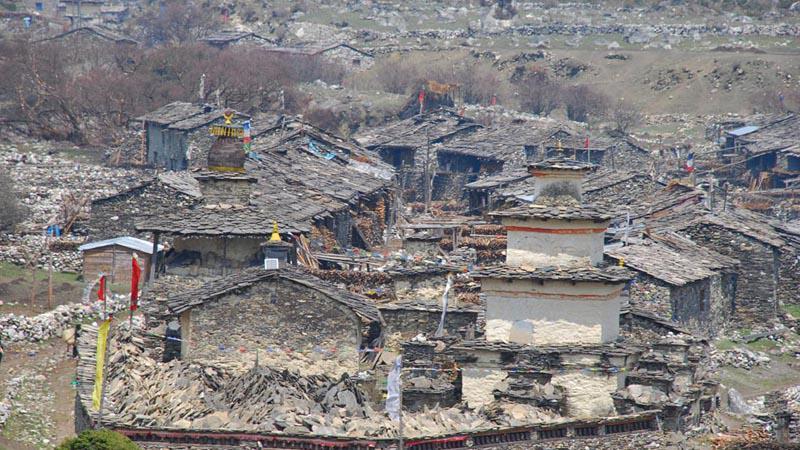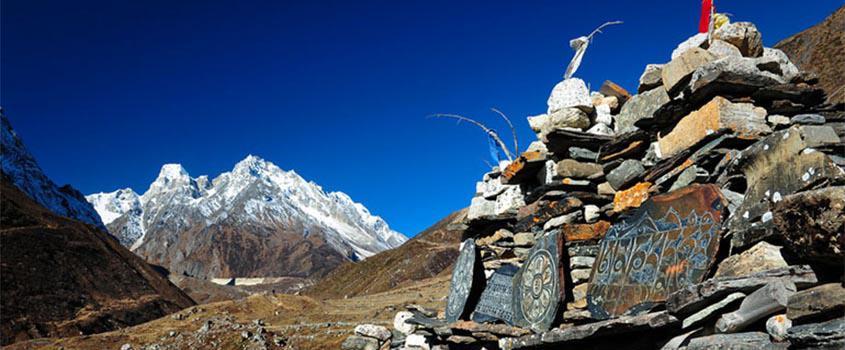The first image is the image on the left, the second image is the image on the right. Analyze the images presented: Is the assertion "An image shows a hillside covered with buildings with windows, and rustic white structures in the foreground." valid? Answer yes or no. No. The first image is the image on the left, the second image is the image on the right. Considering the images on both sides, is "There are flags located on several buildings in one of the images." valid? Answer yes or no. Yes. 